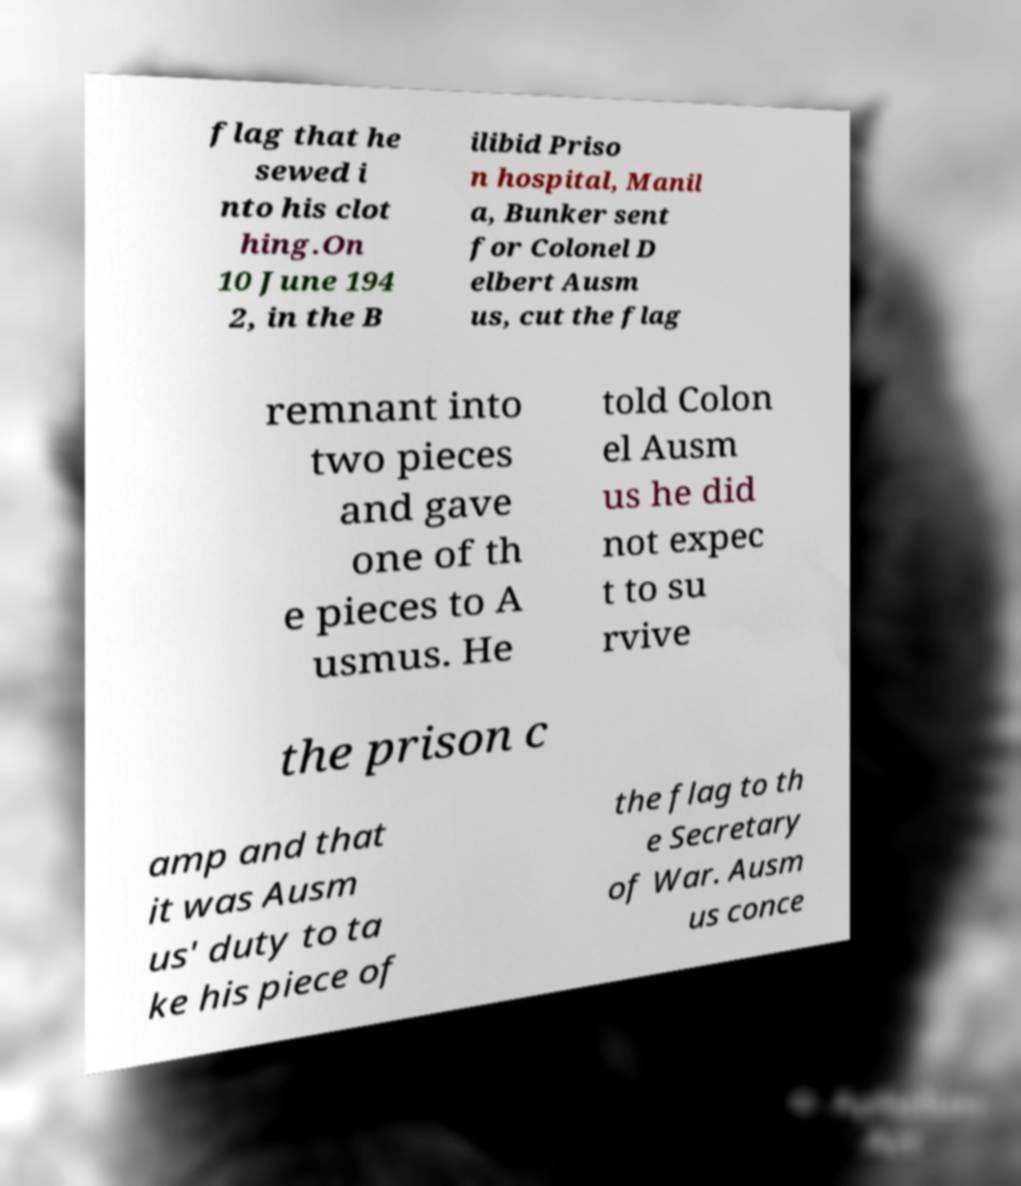Could you extract and type out the text from this image? flag that he sewed i nto his clot hing.On 10 June 194 2, in the B ilibid Priso n hospital, Manil a, Bunker sent for Colonel D elbert Ausm us, cut the flag remnant into two pieces and gave one of th e pieces to A usmus. He told Colon el Ausm us he did not expec t to su rvive the prison c amp and that it was Ausm us' duty to ta ke his piece of the flag to th e Secretary of War. Ausm us conce 